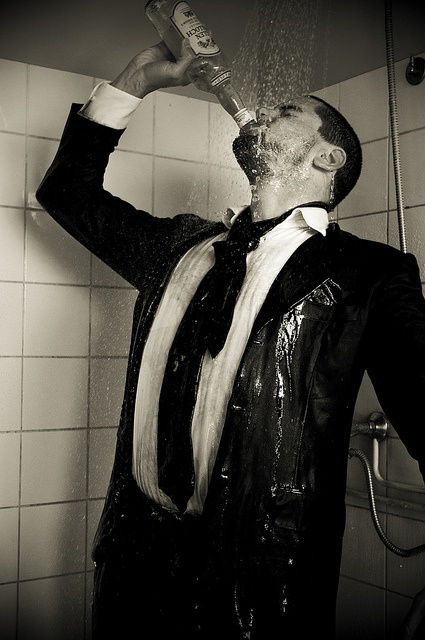Describe the objects in this image and their specific colors. I can see people in black, darkgray, gray, and lightgray tones, tie in black, gray, and darkgray tones, and bottle in black, gray, and darkgray tones in this image. 